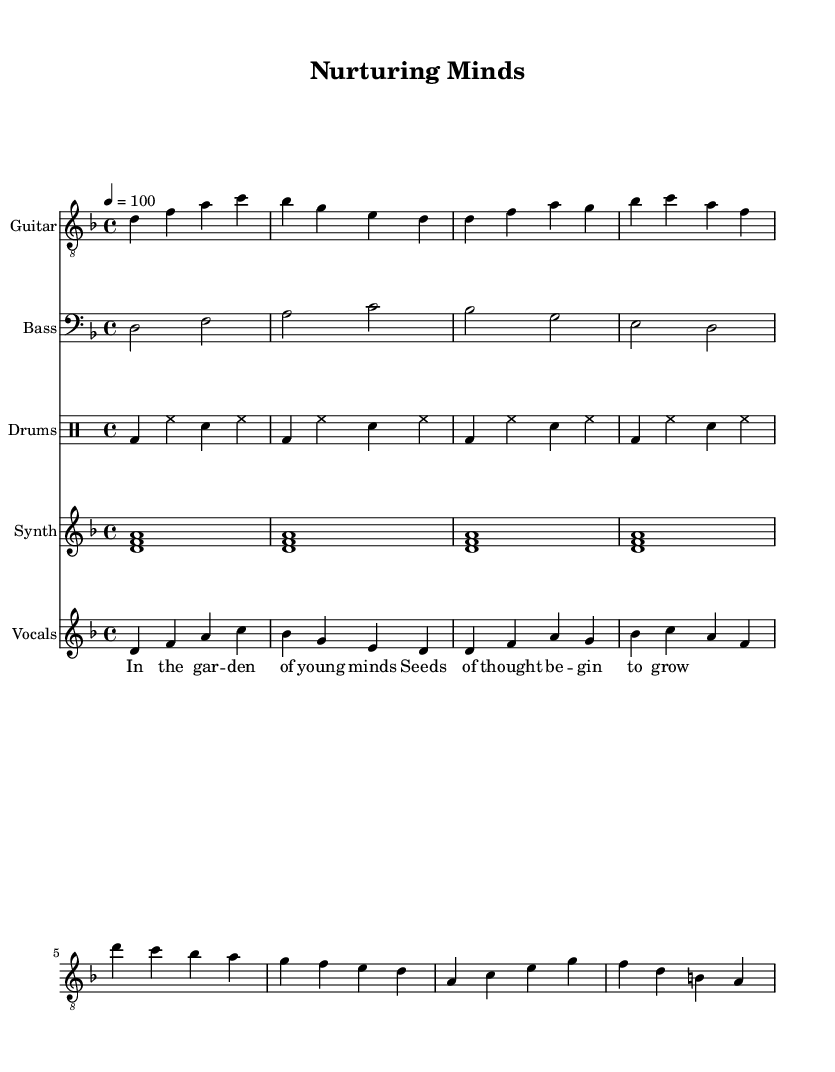What is the key signature of this music? The key signature at the beginning of the music indicates D minor, which is shown with one flat (B flat).
Answer: D minor What is the time signature of the piece? The time signature is displayed right after the key signature as a 4/4, indicating four beats per measure, with a quarter note receiving one beat.
Answer: 4/4 What is the tempo marking for the piece? The tempo marking is specified as quarter note equals 100 beats per minute, which gives the speed of the music.
Answer: 100 How many measures of music are shown for the electric guitar? By counting the vertical lines (barlines) in the electric guitar staff, we can see that there are eight measures in total.
Answer: Eight Which instrument has the highest pitch in the score? The electric guitar part is the highest in pitch as it is written in treble clef and overall contains higher notes compared to the bass and synth parts.
Answer: Electric guitar What is the theme reflected in the lyrics? The lyrics mention a garden and the growth of thoughts, indicating a focus on childhood development and nurturing young minds.
Answer: Childhood development How does the drum pattern contribute to the song's feel? The drum part follows a steady rock beat, providing a solid foundation that complements the soothing yet progressive feel of the metal genre, allowing for introspective lyric delivery.
Answer: Rock beat 